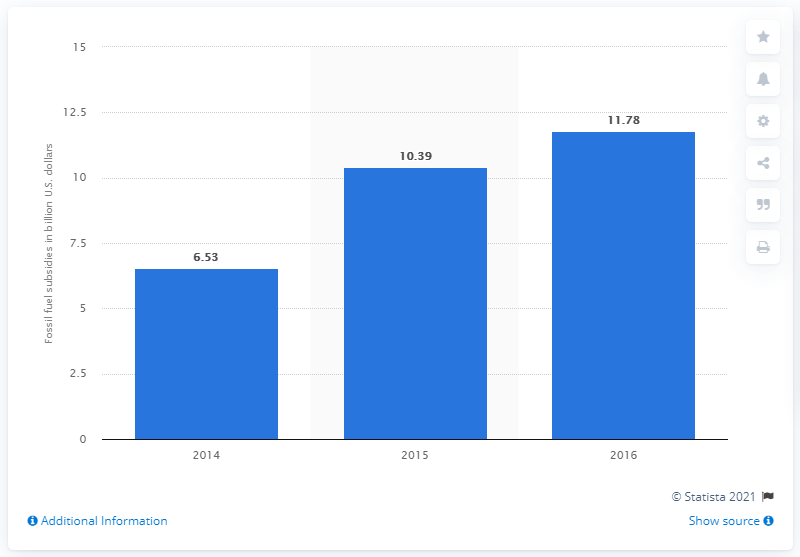Draw attention to some important aspects in this diagram. In 2017, the value of fossil fuel subsidies in Malaysia was 11.78. 